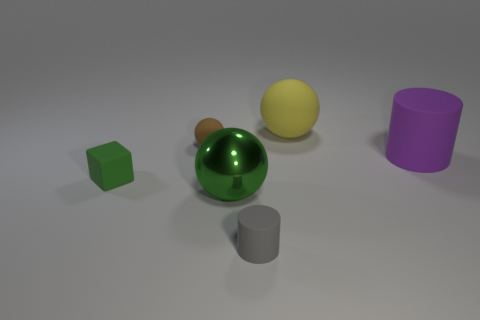Subtract 1 balls. How many balls are left? 2 Subtract all rubber balls. How many balls are left? 1 Add 1 green objects. How many objects exist? 7 Subtract all cubes. How many objects are left? 5 Subtract all blue spheres. Subtract all cyan cylinders. How many spheres are left? 3 Add 6 big purple objects. How many big purple objects are left? 7 Add 5 gray cylinders. How many gray cylinders exist? 6 Subtract 0 cyan blocks. How many objects are left? 6 Subtract all balls. Subtract all big metal spheres. How many objects are left? 2 